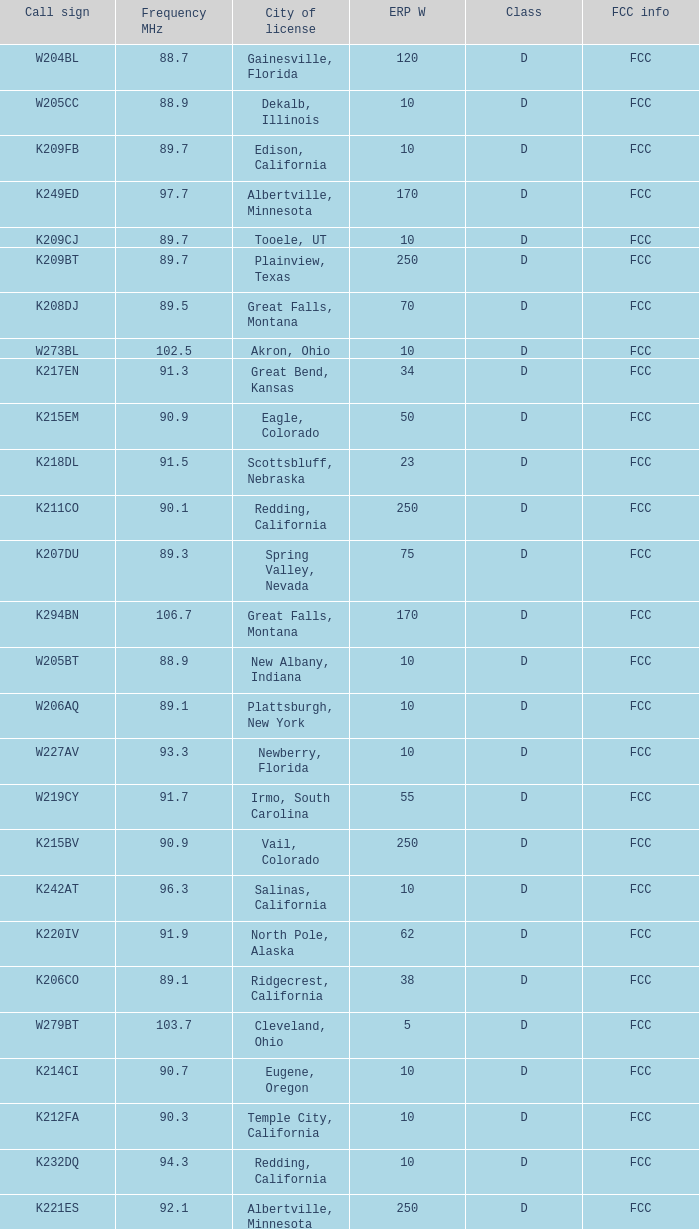What is the call sign of the translator with an ERP W greater than 38 and a city license from Great Falls, Montana? K294BN, K208DJ. 